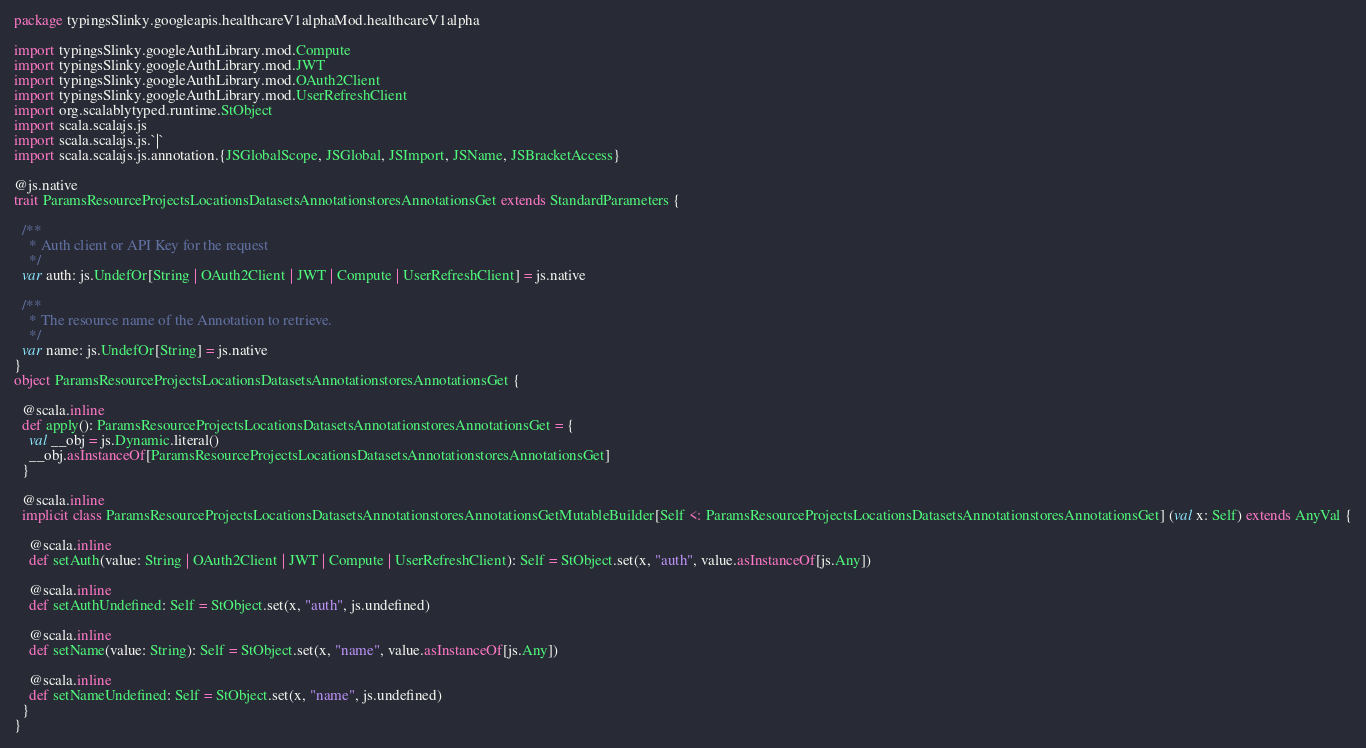<code> <loc_0><loc_0><loc_500><loc_500><_Scala_>package typingsSlinky.googleapis.healthcareV1alphaMod.healthcareV1alpha

import typingsSlinky.googleAuthLibrary.mod.Compute
import typingsSlinky.googleAuthLibrary.mod.JWT
import typingsSlinky.googleAuthLibrary.mod.OAuth2Client
import typingsSlinky.googleAuthLibrary.mod.UserRefreshClient
import org.scalablytyped.runtime.StObject
import scala.scalajs.js
import scala.scalajs.js.`|`
import scala.scalajs.js.annotation.{JSGlobalScope, JSGlobal, JSImport, JSName, JSBracketAccess}

@js.native
trait ParamsResourceProjectsLocationsDatasetsAnnotationstoresAnnotationsGet extends StandardParameters {
  
  /**
    * Auth client or API Key for the request
    */
  var auth: js.UndefOr[String | OAuth2Client | JWT | Compute | UserRefreshClient] = js.native
  
  /**
    * The resource name of the Annotation to retrieve.
    */
  var name: js.UndefOr[String] = js.native
}
object ParamsResourceProjectsLocationsDatasetsAnnotationstoresAnnotationsGet {
  
  @scala.inline
  def apply(): ParamsResourceProjectsLocationsDatasetsAnnotationstoresAnnotationsGet = {
    val __obj = js.Dynamic.literal()
    __obj.asInstanceOf[ParamsResourceProjectsLocationsDatasetsAnnotationstoresAnnotationsGet]
  }
  
  @scala.inline
  implicit class ParamsResourceProjectsLocationsDatasetsAnnotationstoresAnnotationsGetMutableBuilder[Self <: ParamsResourceProjectsLocationsDatasetsAnnotationstoresAnnotationsGet] (val x: Self) extends AnyVal {
    
    @scala.inline
    def setAuth(value: String | OAuth2Client | JWT | Compute | UserRefreshClient): Self = StObject.set(x, "auth", value.asInstanceOf[js.Any])
    
    @scala.inline
    def setAuthUndefined: Self = StObject.set(x, "auth", js.undefined)
    
    @scala.inline
    def setName(value: String): Self = StObject.set(x, "name", value.asInstanceOf[js.Any])
    
    @scala.inline
    def setNameUndefined: Self = StObject.set(x, "name", js.undefined)
  }
}
</code> 